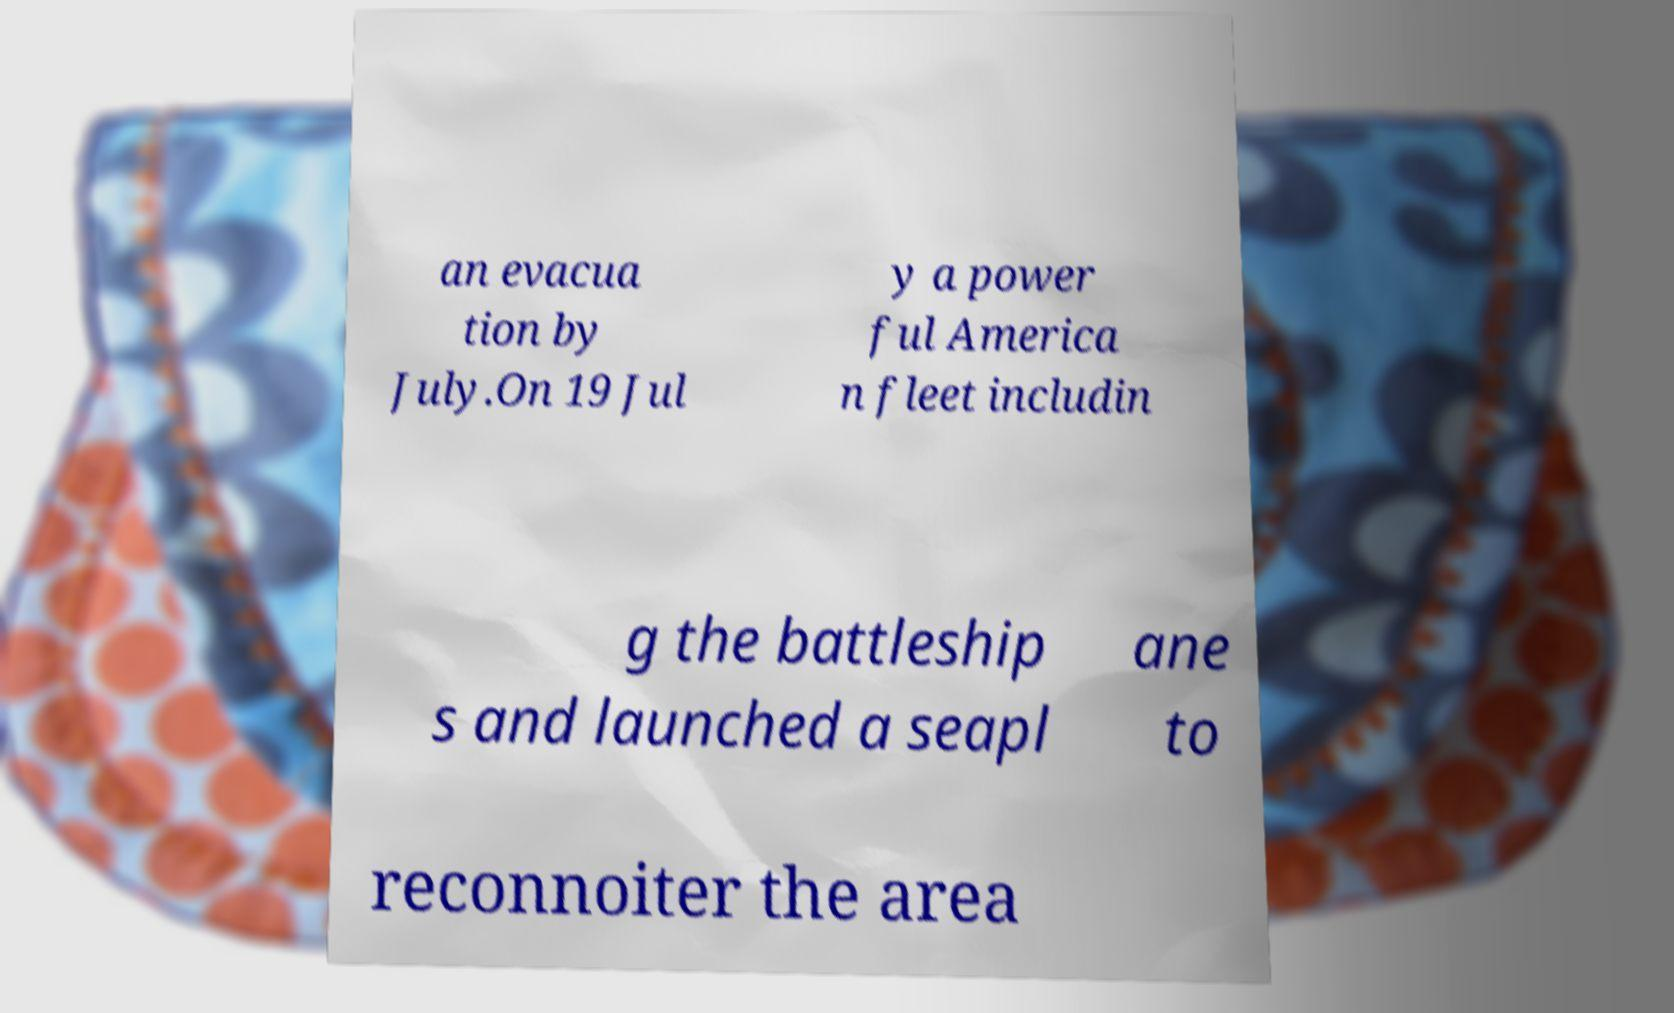There's text embedded in this image that I need extracted. Can you transcribe it verbatim? an evacua tion by July.On 19 Jul y a power ful America n fleet includin g the battleship s and launched a seapl ane to reconnoiter the area 